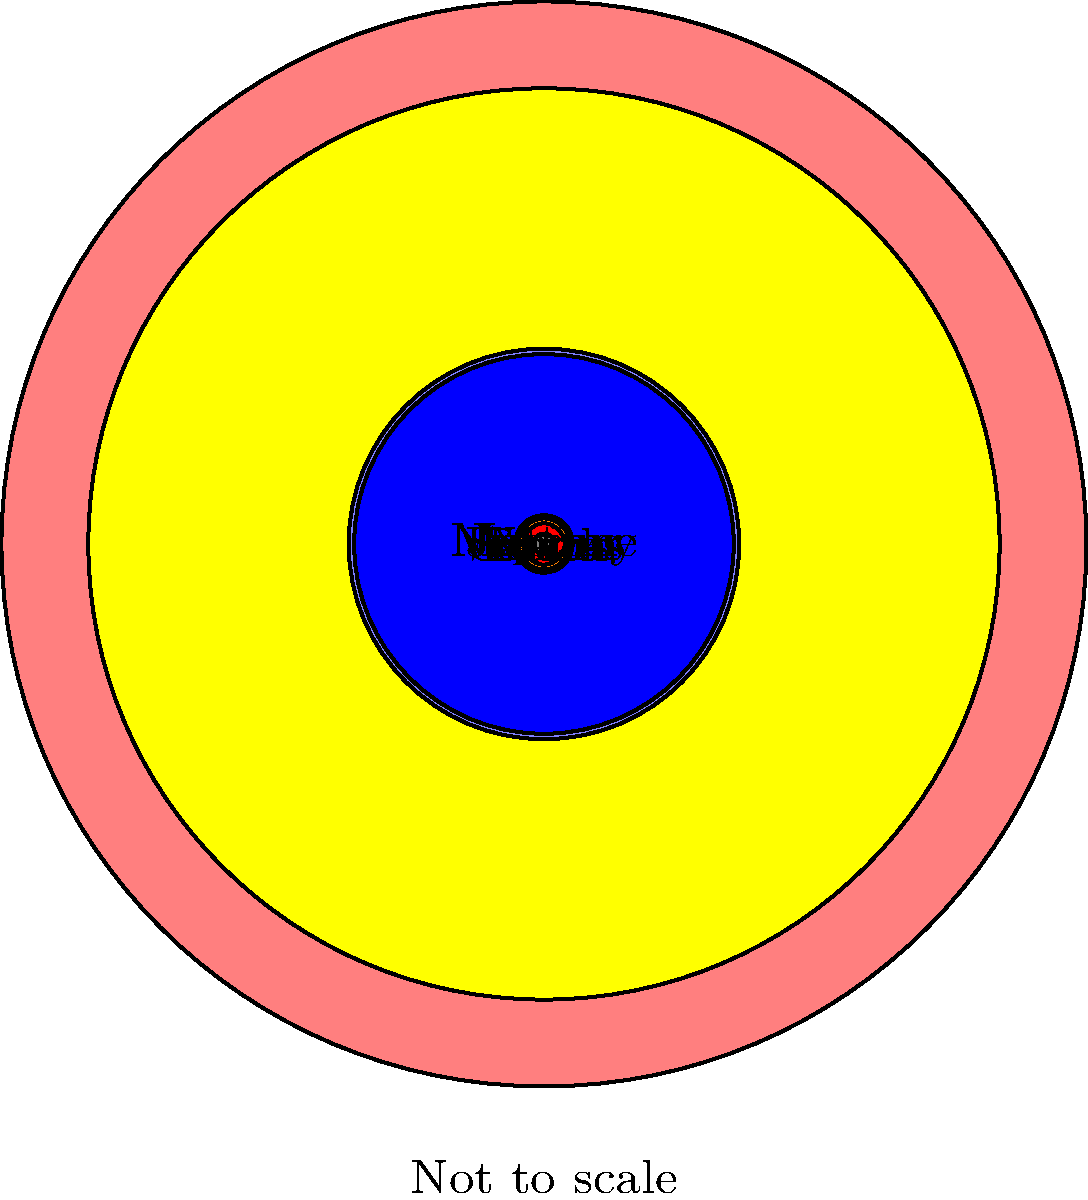In designing a Warhammer game expansion featuring a cosmic battlefield, you need to accurately represent the relative sizes of planets. Based on the diagram, which planet is closest in size to Earth, and what is its approximate diameter relative to Jupiter's? To solve this question, let's follow these steps:

1. Observe the relative sizes of the planets in the diagram.
2. Identify the planet closest in size to Earth.
3. Compare the chosen planet's diameter to Jupiter's.

Step 1: The diagram shows the planets as circles with different sizes. Earth is represented by a small green circle.

Step 2: Looking at the planets near Earth's size, we can see that Venus (orange) is the closest in size to Earth.

Step 3: To find Venus's approximate diameter relative to Jupiter:
- Jupiter's diameter is represented by the largest circle with a radius of 3 units.
- Venus's circle has a radius of approximately 0.047 * 3 = 0.141 units.
- The diameter is twice the radius, so Venus's diameter is about 0.282 units.
- Relative to Jupiter's diameter (6 units), Venus's diameter is:
  $\frac{0.282}{6} \approx 0.047$ or about 4.7% of Jupiter's diameter.

This aligns with the actual relative sizes in our solar system, where Venus is often called Earth's "twin" due to its similar size, and both are much smaller than the gas giants like Jupiter.
Answer: Venus, approximately 4.7% of Jupiter's diameter 